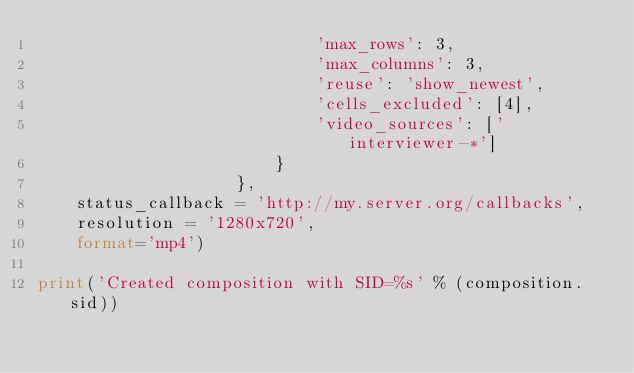Convert code to text. <code><loc_0><loc_0><loc_500><loc_500><_Python_>                            'max_rows': 3,
                            'max_columns': 3,
                            'reuse': 'show_newest',
                            'cells_excluded': [4],
                            'video_sources': ['interviewer-*']
                        }
                    },
    status_callback = 'http://my.server.org/callbacks',
    resolution = '1280x720',
    format='mp4')

print('Created composition with SID=%s' % (composition.sid))
</code> 